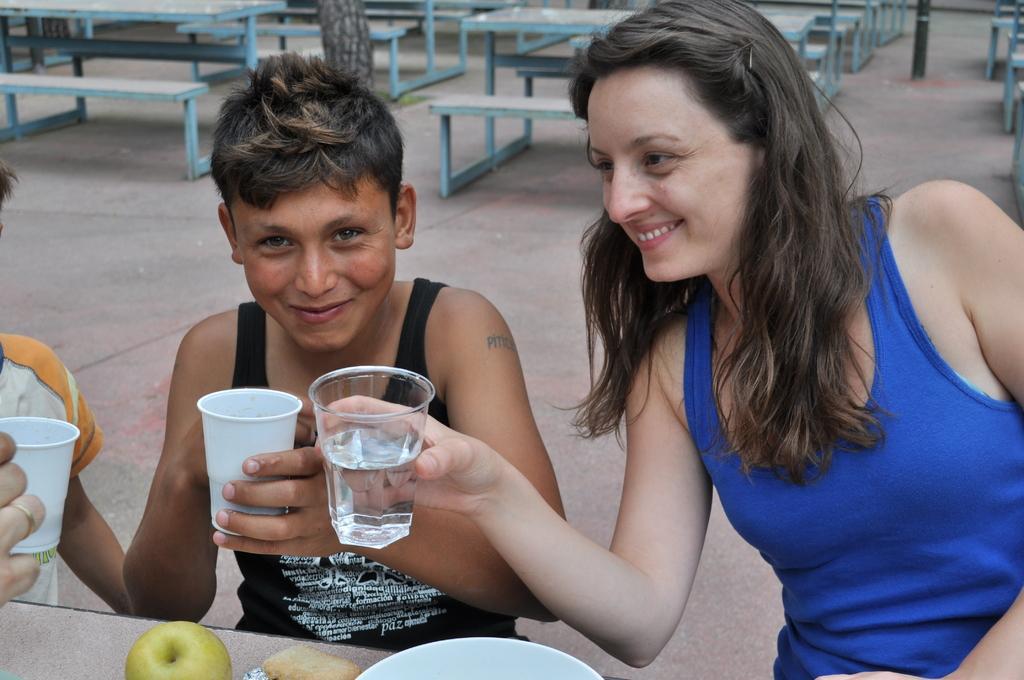Could you give a brief overview of what you see in this image? Here we can see three persons. They are holding glasses with their hands and they are smiling. This is floor and there are benches. Here we can see a bowl and an apple on a surface. 